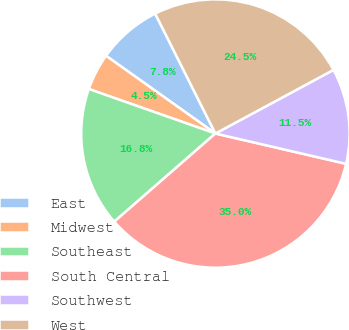<chart> <loc_0><loc_0><loc_500><loc_500><pie_chart><fcel>East<fcel>Midwest<fcel>Southeast<fcel>South Central<fcel>Southwest<fcel>West<nl><fcel>7.76%<fcel>4.45%<fcel>16.79%<fcel>34.96%<fcel>11.49%<fcel>24.54%<nl></chart> 